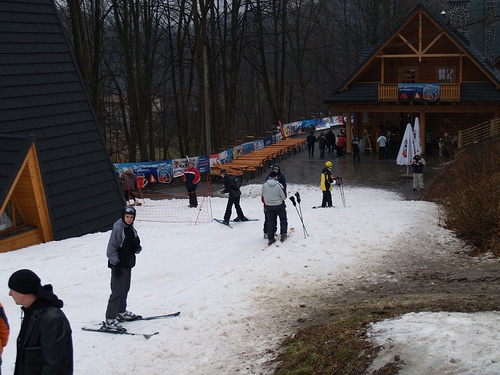Describe the objects in this image and their specific colors. I can see people in black, brown, and lightgray tones, people in black, lightgray, and gray tones, people in black and gray tones, people in black, gray, and maroon tones, and skis in black, lightgray, gray, and darkgray tones in this image. 